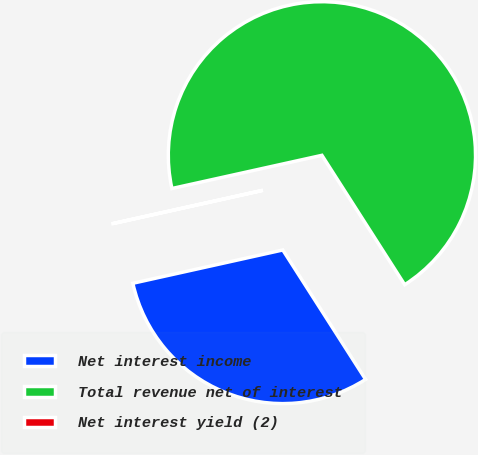Convert chart. <chart><loc_0><loc_0><loc_500><loc_500><pie_chart><fcel>Net interest income<fcel>Total revenue net of interest<fcel>Net interest yield (2)<nl><fcel>30.58%<fcel>69.41%<fcel>0.01%<nl></chart> 